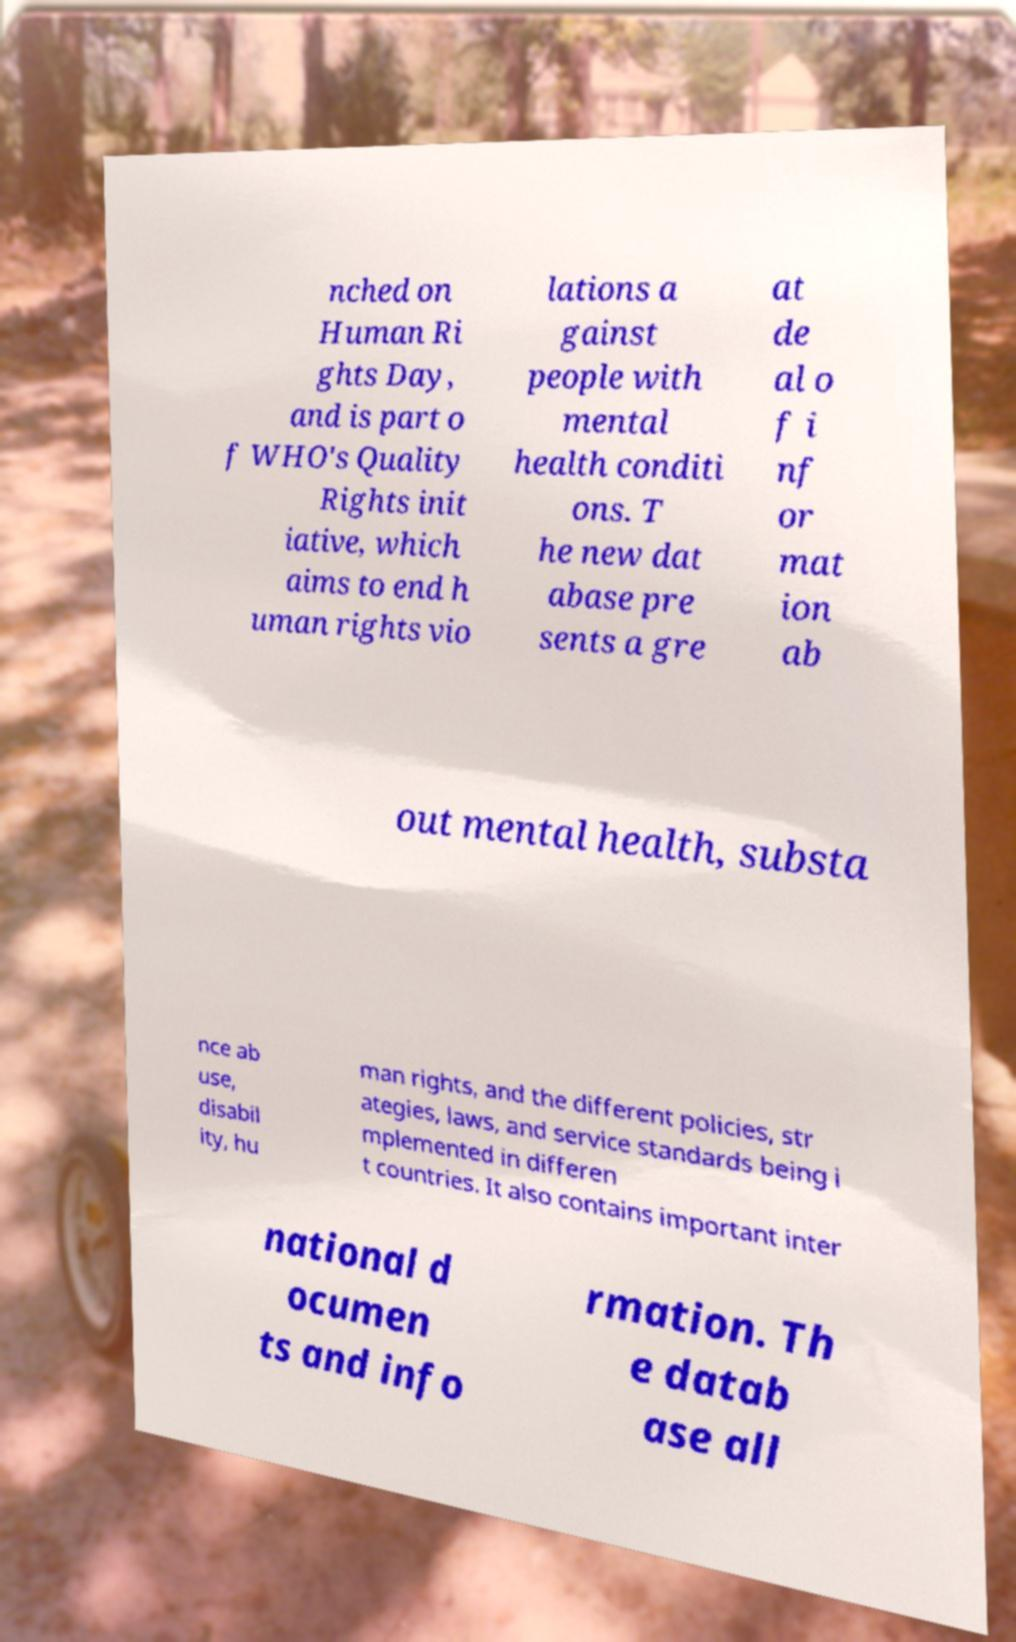There's text embedded in this image that I need extracted. Can you transcribe it verbatim? nched on Human Ri ghts Day, and is part o f WHO's Quality Rights init iative, which aims to end h uman rights vio lations a gainst people with mental health conditi ons. T he new dat abase pre sents a gre at de al o f i nf or mat ion ab out mental health, substa nce ab use, disabil ity, hu man rights, and the different policies, str ategies, laws, and service standards being i mplemented in differen t countries. It also contains important inter national d ocumen ts and info rmation. Th e datab ase all 